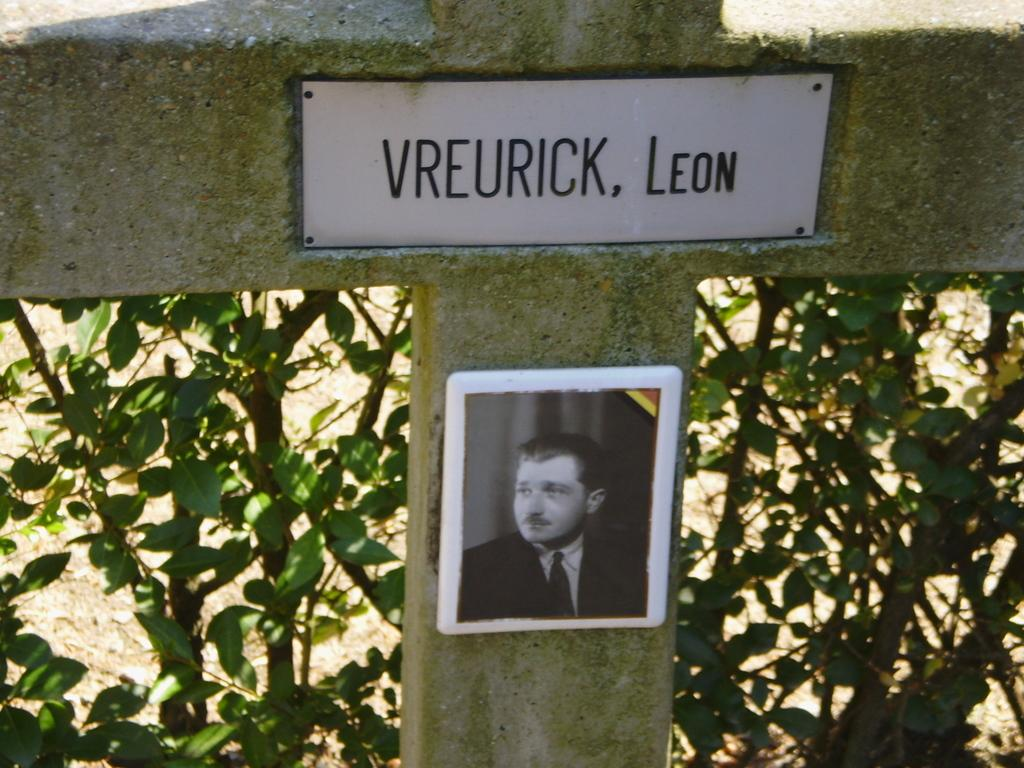What is the main object in the image? There is a cross on a grave in the image. What else can be seen in the image besides the cross? There are plants and a picture in the image. Is there any text or writing in the image? Yes, there is a board with text on the cross in the image. How many cans are visible in the image? There are no cans present in the image. What type of leg is shown supporting the cross in the image? There is no leg shown supporting the cross in the image; it is a grave marker. 